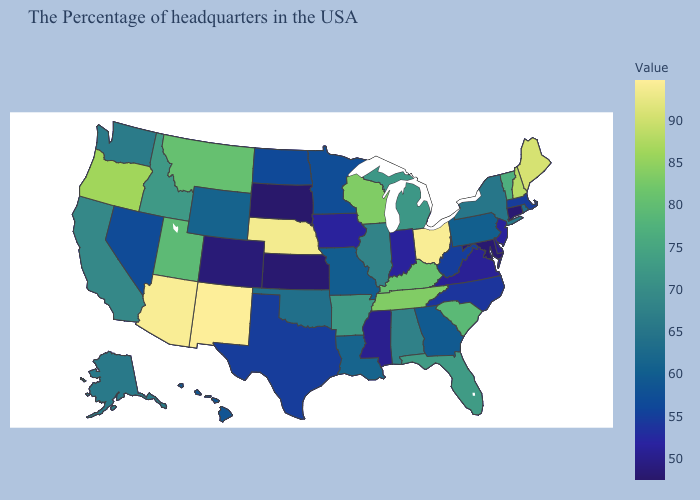Does Michigan have a lower value than Montana?
Be succinct. Yes. Does Tennessee have the highest value in the South?
Give a very brief answer. Yes. Among the states that border West Virginia , does Kentucky have the highest value?
Quick response, please. No. Which states have the lowest value in the USA?
Concise answer only. South Dakota. Among the states that border Massachusetts , which have the highest value?
Write a very short answer. New Hampshire. Does Louisiana have the lowest value in the South?
Short answer required. No. Which states hav the highest value in the West?
Be succinct. New Mexico. Is the legend a continuous bar?
Concise answer only. Yes. 